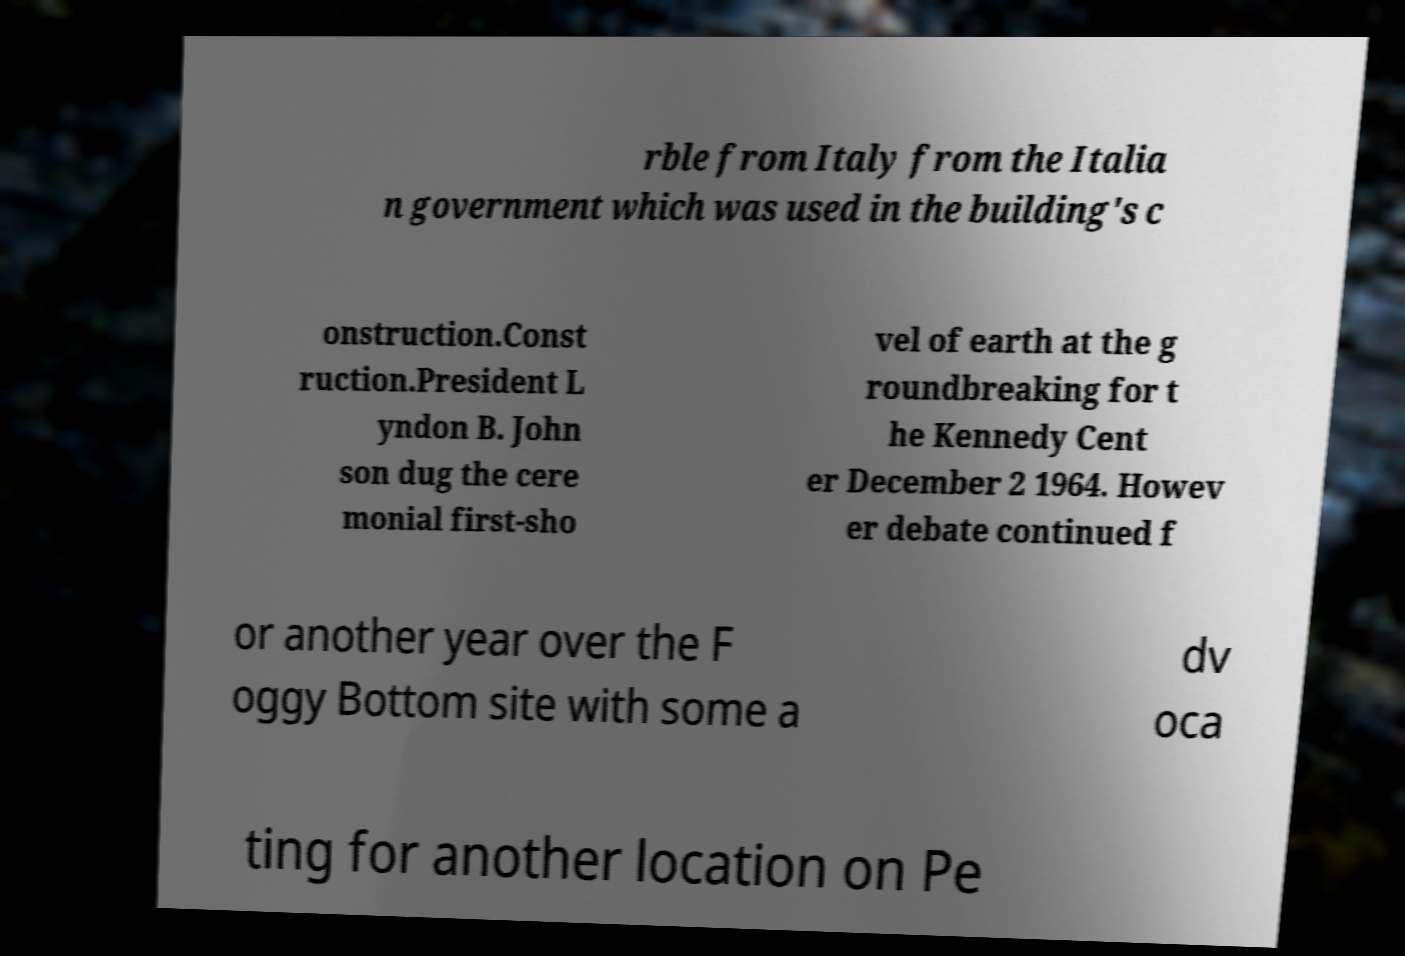Could you assist in decoding the text presented in this image and type it out clearly? rble from Italy from the Italia n government which was used in the building's c onstruction.Const ruction.President L yndon B. John son dug the cere monial first-sho vel of earth at the g roundbreaking for t he Kennedy Cent er December 2 1964. Howev er debate continued f or another year over the F oggy Bottom site with some a dv oca ting for another location on Pe 